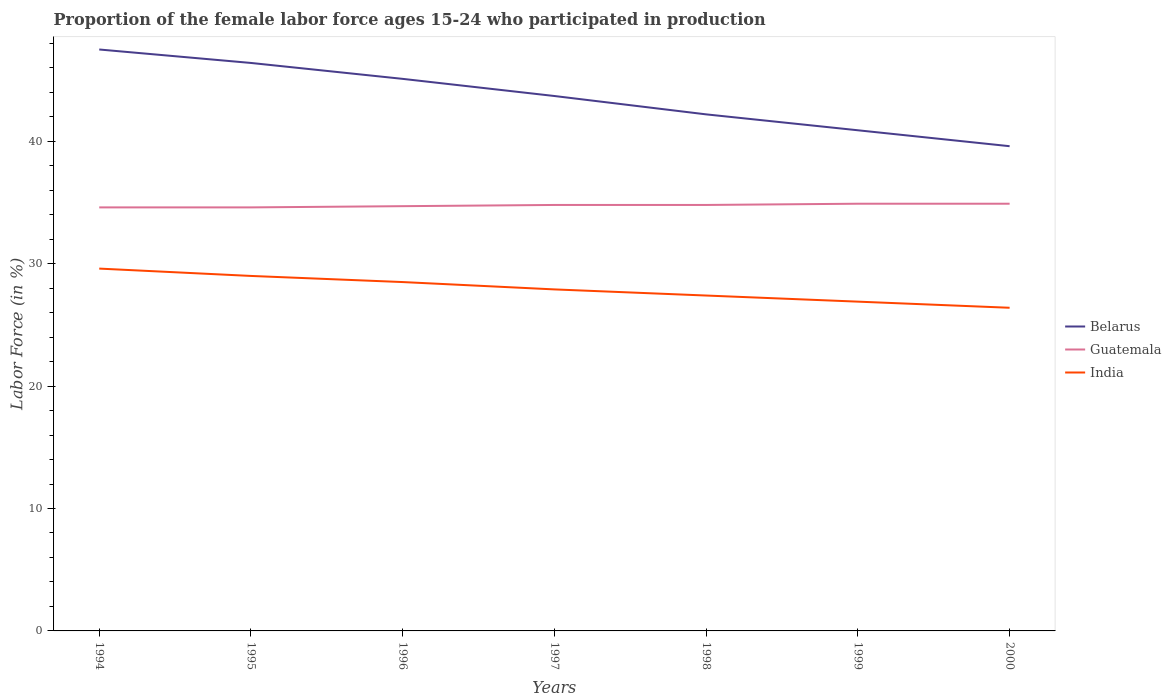Is the number of lines equal to the number of legend labels?
Make the answer very short. Yes. Across all years, what is the maximum proportion of the female labor force who participated in production in Belarus?
Your answer should be compact. 39.6. What is the total proportion of the female labor force who participated in production in Belarus in the graph?
Give a very brief answer. 1.4. What is the difference between the highest and the second highest proportion of the female labor force who participated in production in Guatemala?
Give a very brief answer. 0.3. How many lines are there?
Your response must be concise. 3. How many years are there in the graph?
Your response must be concise. 7. Does the graph contain grids?
Offer a very short reply. No. Where does the legend appear in the graph?
Your answer should be compact. Center right. How many legend labels are there?
Provide a succinct answer. 3. How are the legend labels stacked?
Ensure brevity in your answer.  Vertical. What is the title of the graph?
Make the answer very short. Proportion of the female labor force ages 15-24 who participated in production. Does "Djibouti" appear as one of the legend labels in the graph?
Provide a succinct answer. No. What is the label or title of the X-axis?
Offer a terse response. Years. What is the Labor Force (in %) of Belarus in 1994?
Give a very brief answer. 47.5. What is the Labor Force (in %) of Guatemala in 1994?
Make the answer very short. 34.6. What is the Labor Force (in %) in India in 1994?
Ensure brevity in your answer.  29.6. What is the Labor Force (in %) in Belarus in 1995?
Your response must be concise. 46.4. What is the Labor Force (in %) of Guatemala in 1995?
Give a very brief answer. 34.6. What is the Labor Force (in %) of Belarus in 1996?
Your answer should be very brief. 45.1. What is the Labor Force (in %) of Guatemala in 1996?
Ensure brevity in your answer.  34.7. What is the Labor Force (in %) in India in 1996?
Offer a terse response. 28.5. What is the Labor Force (in %) of Belarus in 1997?
Offer a very short reply. 43.7. What is the Labor Force (in %) of Guatemala in 1997?
Keep it short and to the point. 34.8. What is the Labor Force (in %) of India in 1997?
Your answer should be very brief. 27.9. What is the Labor Force (in %) of Belarus in 1998?
Ensure brevity in your answer.  42.2. What is the Labor Force (in %) of Guatemala in 1998?
Make the answer very short. 34.8. What is the Labor Force (in %) of India in 1998?
Give a very brief answer. 27.4. What is the Labor Force (in %) in Belarus in 1999?
Ensure brevity in your answer.  40.9. What is the Labor Force (in %) of Guatemala in 1999?
Your response must be concise. 34.9. What is the Labor Force (in %) in India in 1999?
Offer a terse response. 26.9. What is the Labor Force (in %) in Belarus in 2000?
Offer a very short reply. 39.6. What is the Labor Force (in %) of Guatemala in 2000?
Your response must be concise. 34.9. What is the Labor Force (in %) of India in 2000?
Offer a terse response. 26.4. Across all years, what is the maximum Labor Force (in %) in Belarus?
Your answer should be compact. 47.5. Across all years, what is the maximum Labor Force (in %) in Guatemala?
Provide a succinct answer. 34.9. Across all years, what is the maximum Labor Force (in %) in India?
Your answer should be very brief. 29.6. Across all years, what is the minimum Labor Force (in %) of Belarus?
Give a very brief answer. 39.6. Across all years, what is the minimum Labor Force (in %) in Guatemala?
Offer a very short reply. 34.6. Across all years, what is the minimum Labor Force (in %) in India?
Provide a succinct answer. 26.4. What is the total Labor Force (in %) in Belarus in the graph?
Ensure brevity in your answer.  305.4. What is the total Labor Force (in %) of Guatemala in the graph?
Offer a very short reply. 243.3. What is the total Labor Force (in %) in India in the graph?
Provide a succinct answer. 195.7. What is the difference between the Labor Force (in %) of Belarus in 1994 and that in 1995?
Make the answer very short. 1.1. What is the difference between the Labor Force (in %) in Guatemala in 1994 and that in 1995?
Offer a terse response. 0. What is the difference between the Labor Force (in %) in India in 1994 and that in 1995?
Offer a terse response. 0.6. What is the difference between the Labor Force (in %) of India in 1994 and that in 1996?
Keep it short and to the point. 1.1. What is the difference between the Labor Force (in %) in Belarus in 1994 and that in 1997?
Offer a very short reply. 3.8. What is the difference between the Labor Force (in %) of Guatemala in 1994 and that in 1997?
Offer a very short reply. -0.2. What is the difference between the Labor Force (in %) of India in 1994 and that in 1997?
Offer a terse response. 1.7. What is the difference between the Labor Force (in %) of India in 1994 and that in 1998?
Keep it short and to the point. 2.2. What is the difference between the Labor Force (in %) of Guatemala in 1994 and that in 1999?
Provide a short and direct response. -0.3. What is the difference between the Labor Force (in %) of Belarus in 1994 and that in 2000?
Offer a terse response. 7.9. What is the difference between the Labor Force (in %) in Guatemala in 1994 and that in 2000?
Provide a succinct answer. -0.3. What is the difference between the Labor Force (in %) of Belarus in 1995 and that in 1996?
Your response must be concise. 1.3. What is the difference between the Labor Force (in %) of Guatemala in 1995 and that in 1996?
Provide a short and direct response. -0.1. What is the difference between the Labor Force (in %) of Guatemala in 1995 and that in 1997?
Offer a very short reply. -0.2. What is the difference between the Labor Force (in %) of Belarus in 1995 and that in 1998?
Your answer should be very brief. 4.2. What is the difference between the Labor Force (in %) of Guatemala in 1995 and that in 1998?
Keep it short and to the point. -0.2. What is the difference between the Labor Force (in %) in India in 1995 and that in 1998?
Keep it short and to the point. 1.6. What is the difference between the Labor Force (in %) in Belarus in 1995 and that in 2000?
Ensure brevity in your answer.  6.8. What is the difference between the Labor Force (in %) of Guatemala in 1996 and that in 1997?
Make the answer very short. -0.1. What is the difference between the Labor Force (in %) of India in 1996 and that in 1997?
Offer a very short reply. 0.6. What is the difference between the Labor Force (in %) in Belarus in 1996 and that in 1998?
Provide a short and direct response. 2.9. What is the difference between the Labor Force (in %) in Belarus in 1996 and that in 1999?
Provide a succinct answer. 4.2. What is the difference between the Labor Force (in %) in Guatemala in 1996 and that in 1999?
Provide a short and direct response. -0.2. What is the difference between the Labor Force (in %) in India in 1996 and that in 1999?
Provide a short and direct response. 1.6. What is the difference between the Labor Force (in %) in Belarus in 1997 and that in 1998?
Make the answer very short. 1.5. What is the difference between the Labor Force (in %) of Guatemala in 1997 and that in 1999?
Make the answer very short. -0.1. What is the difference between the Labor Force (in %) of India in 1997 and that in 1999?
Provide a short and direct response. 1. What is the difference between the Labor Force (in %) of Belarus in 1997 and that in 2000?
Offer a terse response. 4.1. What is the difference between the Labor Force (in %) of Guatemala in 1997 and that in 2000?
Give a very brief answer. -0.1. What is the difference between the Labor Force (in %) in India in 1997 and that in 2000?
Provide a short and direct response. 1.5. What is the difference between the Labor Force (in %) in India in 1998 and that in 1999?
Your response must be concise. 0.5. What is the difference between the Labor Force (in %) of Belarus in 1998 and that in 2000?
Give a very brief answer. 2.6. What is the difference between the Labor Force (in %) of India in 1998 and that in 2000?
Your response must be concise. 1. What is the difference between the Labor Force (in %) of India in 1999 and that in 2000?
Your answer should be compact. 0.5. What is the difference between the Labor Force (in %) in Belarus in 1994 and the Labor Force (in %) in Guatemala in 1995?
Ensure brevity in your answer.  12.9. What is the difference between the Labor Force (in %) in Belarus in 1994 and the Labor Force (in %) in India in 1997?
Your answer should be compact. 19.6. What is the difference between the Labor Force (in %) of Belarus in 1994 and the Labor Force (in %) of Guatemala in 1998?
Provide a short and direct response. 12.7. What is the difference between the Labor Force (in %) of Belarus in 1994 and the Labor Force (in %) of India in 1998?
Offer a terse response. 20.1. What is the difference between the Labor Force (in %) in Guatemala in 1994 and the Labor Force (in %) in India in 1998?
Make the answer very short. 7.2. What is the difference between the Labor Force (in %) in Belarus in 1994 and the Labor Force (in %) in Guatemala in 1999?
Make the answer very short. 12.6. What is the difference between the Labor Force (in %) in Belarus in 1994 and the Labor Force (in %) in India in 1999?
Provide a succinct answer. 20.6. What is the difference between the Labor Force (in %) of Belarus in 1994 and the Labor Force (in %) of India in 2000?
Provide a succinct answer. 21.1. What is the difference between the Labor Force (in %) in Guatemala in 1994 and the Labor Force (in %) in India in 2000?
Offer a terse response. 8.2. What is the difference between the Labor Force (in %) in Belarus in 1995 and the Labor Force (in %) in India in 1996?
Keep it short and to the point. 17.9. What is the difference between the Labor Force (in %) of Guatemala in 1995 and the Labor Force (in %) of India in 1996?
Make the answer very short. 6.1. What is the difference between the Labor Force (in %) of Belarus in 1995 and the Labor Force (in %) of India in 1997?
Ensure brevity in your answer.  18.5. What is the difference between the Labor Force (in %) of Belarus in 1995 and the Labor Force (in %) of India in 1998?
Provide a short and direct response. 19. What is the difference between the Labor Force (in %) in Belarus in 1995 and the Labor Force (in %) in Guatemala in 1999?
Your answer should be very brief. 11.5. What is the difference between the Labor Force (in %) in Belarus in 1995 and the Labor Force (in %) in India in 1999?
Give a very brief answer. 19.5. What is the difference between the Labor Force (in %) in Guatemala in 1995 and the Labor Force (in %) in India in 1999?
Your answer should be compact. 7.7. What is the difference between the Labor Force (in %) of Belarus in 1995 and the Labor Force (in %) of Guatemala in 2000?
Ensure brevity in your answer.  11.5. What is the difference between the Labor Force (in %) in Guatemala in 1995 and the Labor Force (in %) in India in 2000?
Keep it short and to the point. 8.2. What is the difference between the Labor Force (in %) in Belarus in 1996 and the Labor Force (in %) in India in 1997?
Give a very brief answer. 17.2. What is the difference between the Labor Force (in %) of Guatemala in 1996 and the Labor Force (in %) of India in 1997?
Provide a succinct answer. 6.8. What is the difference between the Labor Force (in %) of Belarus in 1996 and the Labor Force (in %) of India in 1998?
Offer a very short reply. 17.7. What is the difference between the Labor Force (in %) in Belarus in 1996 and the Labor Force (in %) in Guatemala in 1999?
Make the answer very short. 10.2. What is the difference between the Labor Force (in %) in Belarus in 1996 and the Labor Force (in %) in India in 1999?
Provide a succinct answer. 18.2. What is the difference between the Labor Force (in %) in Guatemala in 1996 and the Labor Force (in %) in India in 1999?
Offer a very short reply. 7.8. What is the difference between the Labor Force (in %) of Belarus in 1996 and the Labor Force (in %) of Guatemala in 2000?
Your response must be concise. 10.2. What is the difference between the Labor Force (in %) in Guatemala in 1996 and the Labor Force (in %) in India in 2000?
Give a very brief answer. 8.3. What is the difference between the Labor Force (in %) in Belarus in 1997 and the Labor Force (in %) in Guatemala in 1998?
Keep it short and to the point. 8.9. What is the difference between the Labor Force (in %) in Guatemala in 1997 and the Labor Force (in %) in India in 1998?
Your answer should be very brief. 7.4. What is the difference between the Labor Force (in %) of Belarus in 1997 and the Labor Force (in %) of India in 1999?
Offer a terse response. 16.8. What is the difference between the Labor Force (in %) in Guatemala in 1997 and the Labor Force (in %) in India in 1999?
Offer a terse response. 7.9. What is the difference between the Labor Force (in %) of Belarus in 1997 and the Labor Force (in %) of India in 2000?
Your response must be concise. 17.3. What is the difference between the Labor Force (in %) of Guatemala in 1997 and the Labor Force (in %) of India in 2000?
Offer a very short reply. 8.4. What is the difference between the Labor Force (in %) in Guatemala in 1998 and the Labor Force (in %) in India in 1999?
Keep it short and to the point. 7.9. What is the difference between the Labor Force (in %) of Guatemala in 1998 and the Labor Force (in %) of India in 2000?
Offer a very short reply. 8.4. What is the difference between the Labor Force (in %) of Belarus in 1999 and the Labor Force (in %) of Guatemala in 2000?
Provide a short and direct response. 6. What is the average Labor Force (in %) of Belarus per year?
Give a very brief answer. 43.63. What is the average Labor Force (in %) of Guatemala per year?
Offer a very short reply. 34.76. What is the average Labor Force (in %) in India per year?
Give a very brief answer. 27.96. In the year 1994, what is the difference between the Labor Force (in %) of Belarus and Labor Force (in %) of Guatemala?
Offer a very short reply. 12.9. In the year 1994, what is the difference between the Labor Force (in %) of Belarus and Labor Force (in %) of India?
Give a very brief answer. 17.9. In the year 1994, what is the difference between the Labor Force (in %) in Guatemala and Labor Force (in %) in India?
Your answer should be compact. 5. In the year 1995, what is the difference between the Labor Force (in %) of Belarus and Labor Force (in %) of India?
Ensure brevity in your answer.  17.4. In the year 1995, what is the difference between the Labor Force (in %) of Guatemala and Labor Force (in %) of India?
Make the answer very short. 5.6. In the year 1996, what is the difference between the Labor Force (in %) in Belarus and Labor Force (in %) in Guatemala?
Your answer should be compact. 10.4. In the year 1996, what is the difference between the Labor Force (in %) of Guatemala and Labor Force (in %) of India?
Provide a short and direct response. 6.2. In the year 1997, what is the difference between the Labor Force (in %) of Belarus and Labor Force (in %) of Guatemala?
Offer a terse response. 8.9. In the year 1997, what is the difference between the Labor Force (in %) in Guatemala and Labor Force (in %) in India?
Your answer should be compact. 6.9. In the year 1999, what is the difference between the Labor Force (in %) in Belarus and Labor Force (in %) in India?
Give a very brief answer. 14. In the year 1999, what is the difference between the Labor Force (in %) in Guatemala and Labor Force (in %) in India?
Your response must be concise. 8. In the year 2000, what is the difference between the Labor Force (in %) in Belarus and Labor Force (in %) in Guatemala?
Offer a very short reply. 4.7. In the year 2000, what is the difference between the Labor Force (in %) of Guatemala and Labor Force (in %) of India?
Provide a succinct answer. 8.5. What is the ratio of the Labor Force (in %) in Belarus in 1994 to that in 1995?
Ensure brevity in your answer.  1.02. What is the ratio of the Labor Force (in %) in Guatemala in 1994 to that in 1995?
Offer a terse response. 1. What is the ratio of the Labor Force (in %) of India in 1994 to that in 1995?
Make the answer very short. 1.02. What is the ratio of the Labor Force (in %) of Belarus in 1994 to that in 1996?
Provide a short and direct response. 1.05. What is the ratio of the Labor Force (in %) of India in 1994 to that in 1996?
Ensure brevity in your answer.  1.04. What is the ratio of the Labor Force (in %) in Belarus in 1994 to that in 1997?
Make the answer very short. 1.09. What is the ratio of the Labor Force (in %) of Guatemala in 1994 to that in 1997?
Ensure brevity in your answer.  0.99. What is the ratio of the Labor Force (in %) in India in 1994 to that in 1997?
Provide a succinct answer. 1.06. What is the ratio of the Labor Force (in %) in Belarus in 1994 to that in 1998?
Your answer should be very brief. 1.13. What is the ratio of the Labor Force (in %) in India in 1994 to that in 1998?
Ensure brevity in your answer.  1.08. What is the ratio of the Labor Force (in %) in Belarus in 1994 to that in 1999?
Your answer should be very brief. 1.16. What is the ratio of the Labor Force (in %) of India in 1994 to that in 1999?
Make the answer very short. 1.1. What is the ratio of the Labor Force (in %) in Belarus in 1994 to that in 2000?
Provide a succinct answer. 1.2. What is the ratio of the Labor Force (in %) of India in 1994 to that in 2000?
Provide a short and direct response. 1.12. What is the ratio of the Labor Force (in %) in Belarus in 1995 to that in 1996?
Provide a short and direct response. 1.03. What is the ratio of the Labor Force (in %) of India in 1995 to that in 1996?
Provide a succinct answer. 1.02. What is the ratio of the Labor Force (in %) in Belarus in 1995 to that in 1997?
Provide a succinct answer. 1.06. What is the ratio of the Labor Force (in %) of Guatemala in 1995 to that in 1997?
Keep it short and to the point. 0.99. What is the ratio of the Labor Force (in %) in India in 1995 to that in 1997?
Offer a terse response. 1.04. What is the ratio of the Labor Force (in %) in Belarus in 1995 to that in 1998?
Provide a succinct answer. 1.1. What is the ratio of the Labor Force (in %) of Guatemala in 1995 to that in 1998?
Your answer should be very brief. 0.99. What is the ratio of the Labor Force (in %) in India in 1995 to that in 1998?
Keep it short and to the point. 1.06. What is the ratio of the Labor Force (in %) of Belarus in 1995 to that in 1999?
Provide a succinct answer. 1.13. What is the ratio of the Labor Force (in %) in India in 1995 to that in 1999?
Give a very brief answer. 1.08. What is the ratio of the Labor Force (in %) of Belarus in 1995 to that in 2000?
Give a very brief answer. 1.17. What is the ratio of the Labor Force (in %) of India in 1995 to that in 2000?
Offer a very short reply. 1.1. What is the ratio of the Labor Force (in %) of Belarus in 1996 to that in 1997?
Offer a very short reply. 1.03. What is the ratio of the Labor Force (in %) in India in 1996 to that in 1997?
Provide a short and direct response. 1.02. What is the ratio of the Labor Force (in %) of Belarus in 1996 to that in 1998?
Provide a short and direct response. 1.07. What is the ratio of the Labor Force (in %) in India in 1996 to that in 1998?
Your response must be concise. 1.04. What is the ratio of the Labor Force (in %) in Belarus in 1996 to that in 1999?
Provide a succinct answer. 1.1. What is the ratio of the Labor Force (in %) of Guatemala in 1996 to that in 1999?
Offer a very short reply. 0.99. What is the ratio of the Labor Force (in %) in India in 1996 to that in 1999?
Keep it short and to the point. 1.06. What is the ratio of the Labor Force (in %) in Belarus in 1996 to that in 2000?
Ensure brevity in your answer.  1.14. What is the ratio of the Labor Force (in %) of Guatemala in 1996 to that in 2000?
Offer a terse response. 0.99. What is the ratio of the Labor Force (in %) in India in 1996 to that in 2000?
Provide a succinct answer. 1.08. What is the ratio of the Labor Force (in %) in Belarus in 1997 to that in 1998?
Make the answer very short. 1.04. What is the ratio of the Labor Force (in %) of Guatemala in 1997 to that in 1998?
Make the answer very short. 1. What is the ratio of the Labor Force (in %) of India in 1997 to that in 1998?
Ensure brevity in your answer.  1.02. What is the ratio of the Labor Force (in %) in Belarus in 1997 to that in 1999?
Keep it short and to the point. 1.07. What is the ratio of the Labor Force (in %) in Guatemala in 1997 to that in 1999?
Your answer should be very brief. 1. What is the ratio of the Labor Force (in %) of India in 1997 to that in 1999?
Ensure brevity in your answer.  1.04. What is the ratio of the Labor Force (in %) of Belarus in 1997 to that in 2000?
Offer a terse response. 1.1. What is the ratio of the Labor Force (in %) of Guatemala in 1997 to that in 2000?
Your response must be concise. 1. What is the ratio of the Labor Force (in %) of India in 1997 to that in 2000?
Your answer should be very brief. 1.06. What is the ratio of the Labor Force (in %) in Belarus in 1998 to that in 1999?
Give a very brief answer. 1.03. What is the ratio of the Labor Force (in %) of Guatemala in 1998 to that in 1999?
Offer a very short reply. 1. What is the ratio of the Labor Force (in %) of India in 1998 to that in 1999?
Offer a terse response. 1.02. What is the ratio of the Labor Force (in %) of Belarus in 1998 to that in 2000?
Your answer should be very brief. 1.07. What is the ratio of the Labor Force (in %) in India in 1998 to that in 2000?
Your response must be concise. 1.04. What is the ratio of the Labor Force (in %) in Belarus in 1999 to that in 2000?
Provide a short and direct response. 1.03. What is the ratio of the Labor Force (in %) of India in 1999 to that in 2000?
Your answer should be compact. 1.02. What is the difference between the highest and the second highest Labor Force (in %) of Belarus?
Ensure brevity in your answer.  1.1. What is the difference between the highest and the second highest Labor Force (in %) of Guatemala?
Provide a short and direct response. 0. What is the difference between the highest and the lowest Labor Force (in %) in Belarus?
Offer a terse response. 7.9. 